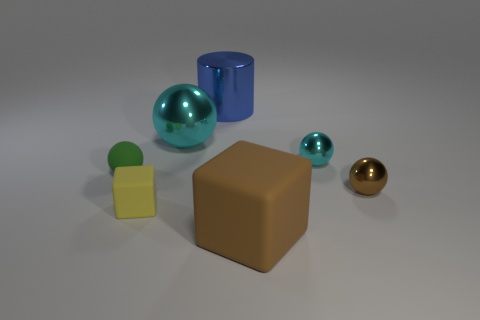Are there any gray cylinders that have the same size as the yellow rubber thing?
Your answer should be very brief. No. Do the small shiny sphere that is behind the green matte sphere and the large ball have the same color?
Offer a terse response. Yes. How many brown things are tiny matte things or tiny matte balls?
Your answer should be compact. 0. How many metal things have the same color as the tiny block?
Your answer should be compact. 0. Is the material of the small cube the same as the small green sphere?
Give a very brief answer. Yes. How many small green rubber objects are on the right side of the tiny shiny ball in front of the green sphere?
Your answer should be compact. 0. Do the yellow matte object and the green object have the same size?
Give a very brief answer. Yes. How many other objects have the same material as the big blue object?
Your answer should be very brief. 3. There is a brown metallic object that is the same shape as the green rubber thing; what is its size?
Ensure brevity in your answer.  Small. There is a metallic thing that is in front of the green matte ball; is its shape the same as the large cyan metallic object?
Give a very brief answer. Yes. 